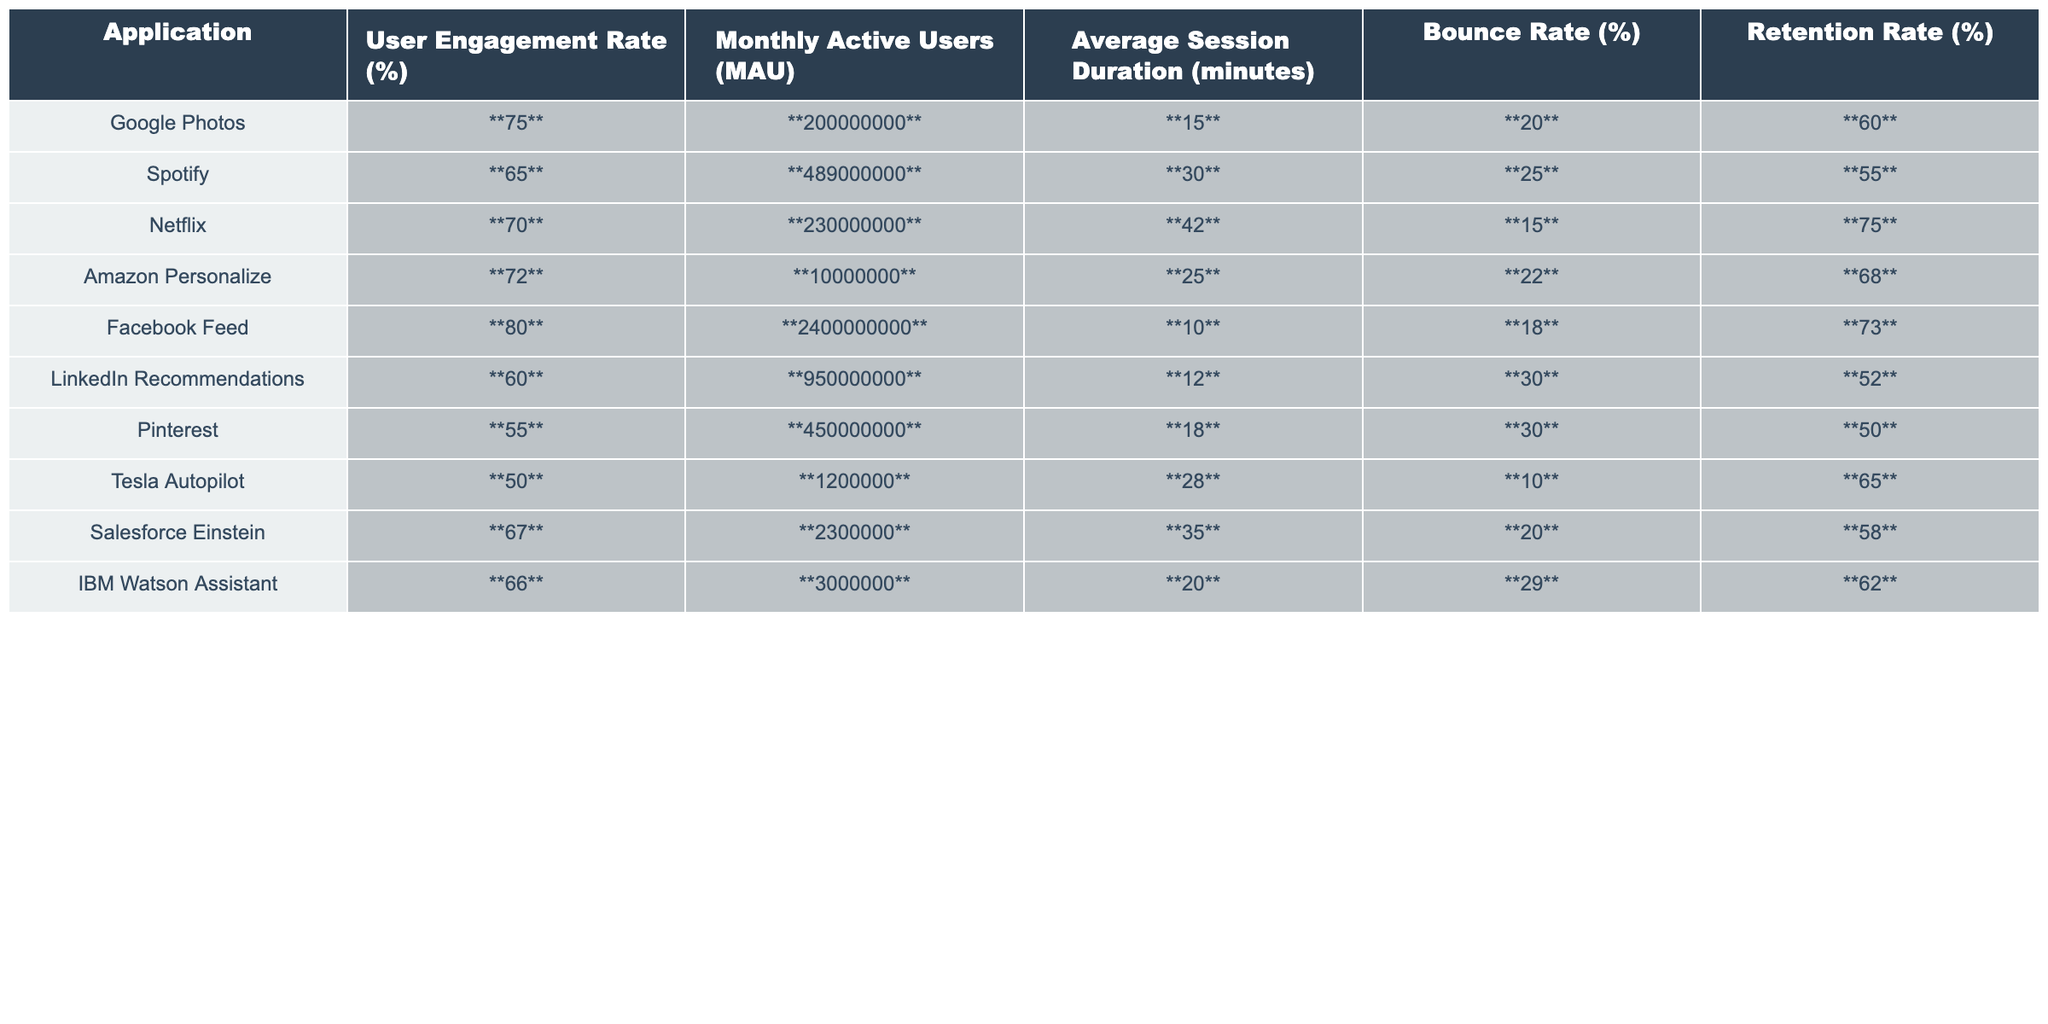What is the User Engagement Rate for Netflix? The User Engagement Rate for Netflix is clearly indicated in the table, which is directly stated as 70%.
Answer: 70% Which application has the highest Monthly Active Users (MAU)? Reviewing the Monthly Active Users column, Facebook Feed has the highest value at 2,400,000,000 users.
Answer: Facebook Feed What is the Average Session Duration for Spotify? The Average Session Duration is stated as 30 minutes in the table under the corresponding column for Spotify.
Answer: 30 minutes How many applications have a Retention Rate greater than 60%? Analyzing the Retention Rate column, Netflix (75%), Google Photos (60%), and Amazon Personalize (68%) exceed 60%. Therefore, 3 applications meet this criterion.
Answer: 3 What is the difference in Bounce Rate between Google Photos and Tesla Autopilot? Looking at the Bounce Rate, Google Photos has 20% and Tesla Autopilot has 10%. The difference is 20% - 10% = 10%.
Answer: 10% Is the Average Session Duration for LinkedIn Recommendations more than 25 minutes? The Average Session Duration for LinkedIn Recommendations is 12 minutes, which is less than 25 minutes, so the statement is false.
Answer: No What is the average User Engagement Rate for the listed applications? To find the average, we sum the User Engagement Rates: (75 + 65 + 70 + 72 + 80 + 60 + 55 + 50 + 67 + 66) / 10 = 66.5%.
Answer: 66.5% Which two applications have the lowest Bounce Rate? Observing the Bounce Rate column, Tesla Autopilot (10%) and Netflix (15%) are the two with the lowest rates.
Answer: Tesla Autopilot and Netflix If you combine the Monthly Active Users for Amazon Personalize and Salesforce Einstein, what is the total? The Monthly Active Users for Amazon Personalize is 10,000,000 and Salesforce Einstein is 2,300,000. Adding these gives 10,000,000 + 2,300,000 = 12,300,000.
Answer: 12,300,000 Which application has the highest retention rate and what is that rate? The highest retention rate is 75%, which belongs to Netflix. This is found by examining the Retention Rate column.
Answer: Netflix, 75% 